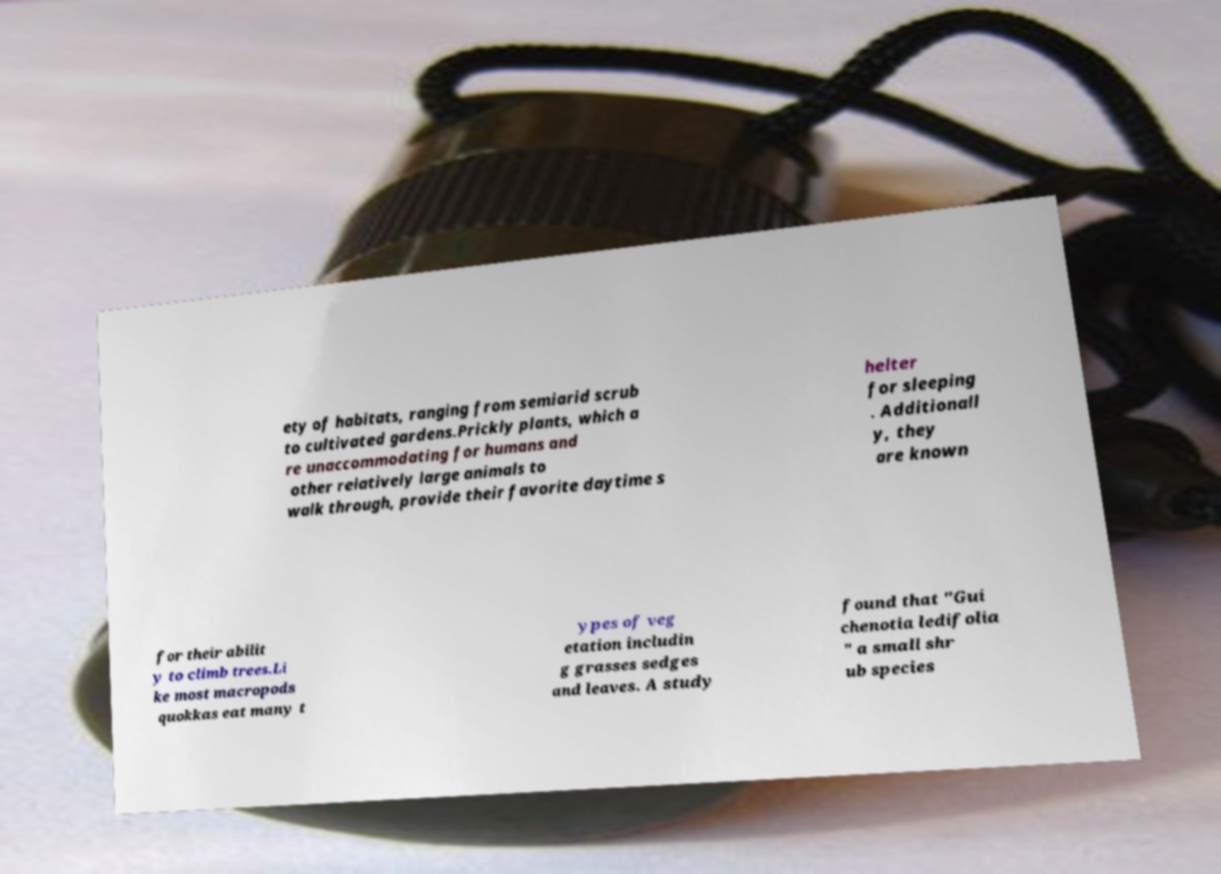Please identify and transcribe the text found in this image. ety of habitats, ranging from semiarid scrub to cultivated gardens.Prickly plants, which a re unaccommodating for humans and other relatively large animals to walk through, provide their favorite daytime s helter for sleeping . Additionall y, they are known for their abilit y to climb trees.Li ke most macropods quokkas eat many t ypes of veg etation includin g grasses sedges and leaves. A study found that "Gui chenotia ledifolia " a small shr ub species 